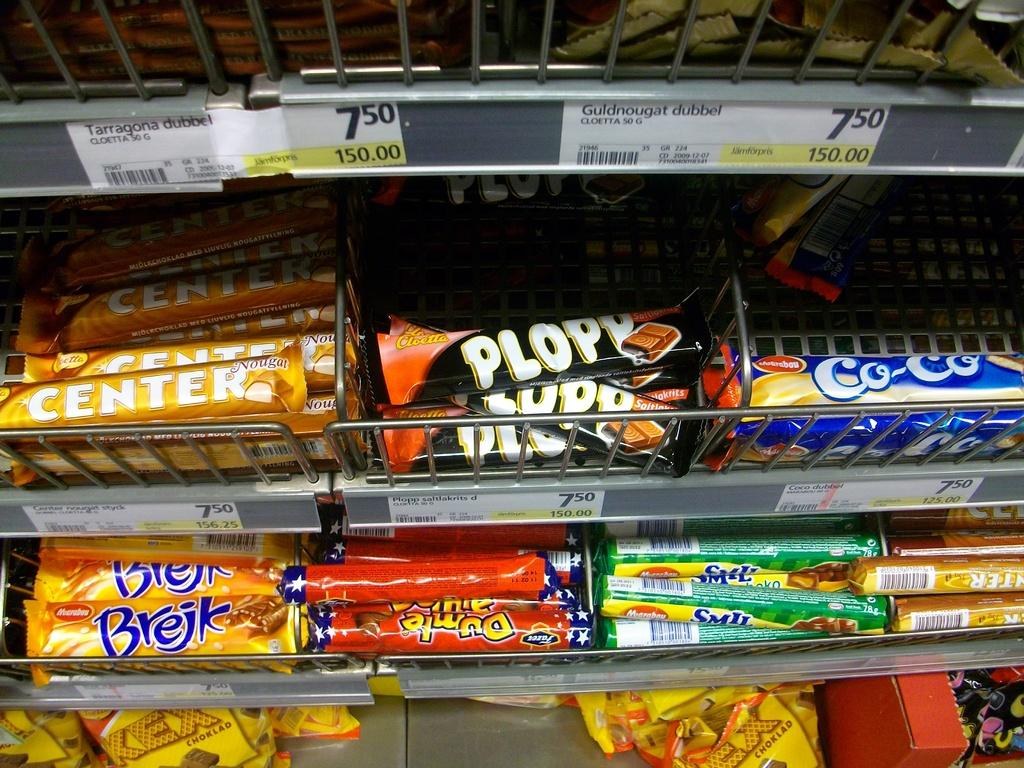<image>
Relay a brief, clear account of the picture shown. a display of different candy bars with the top middle called plopp 